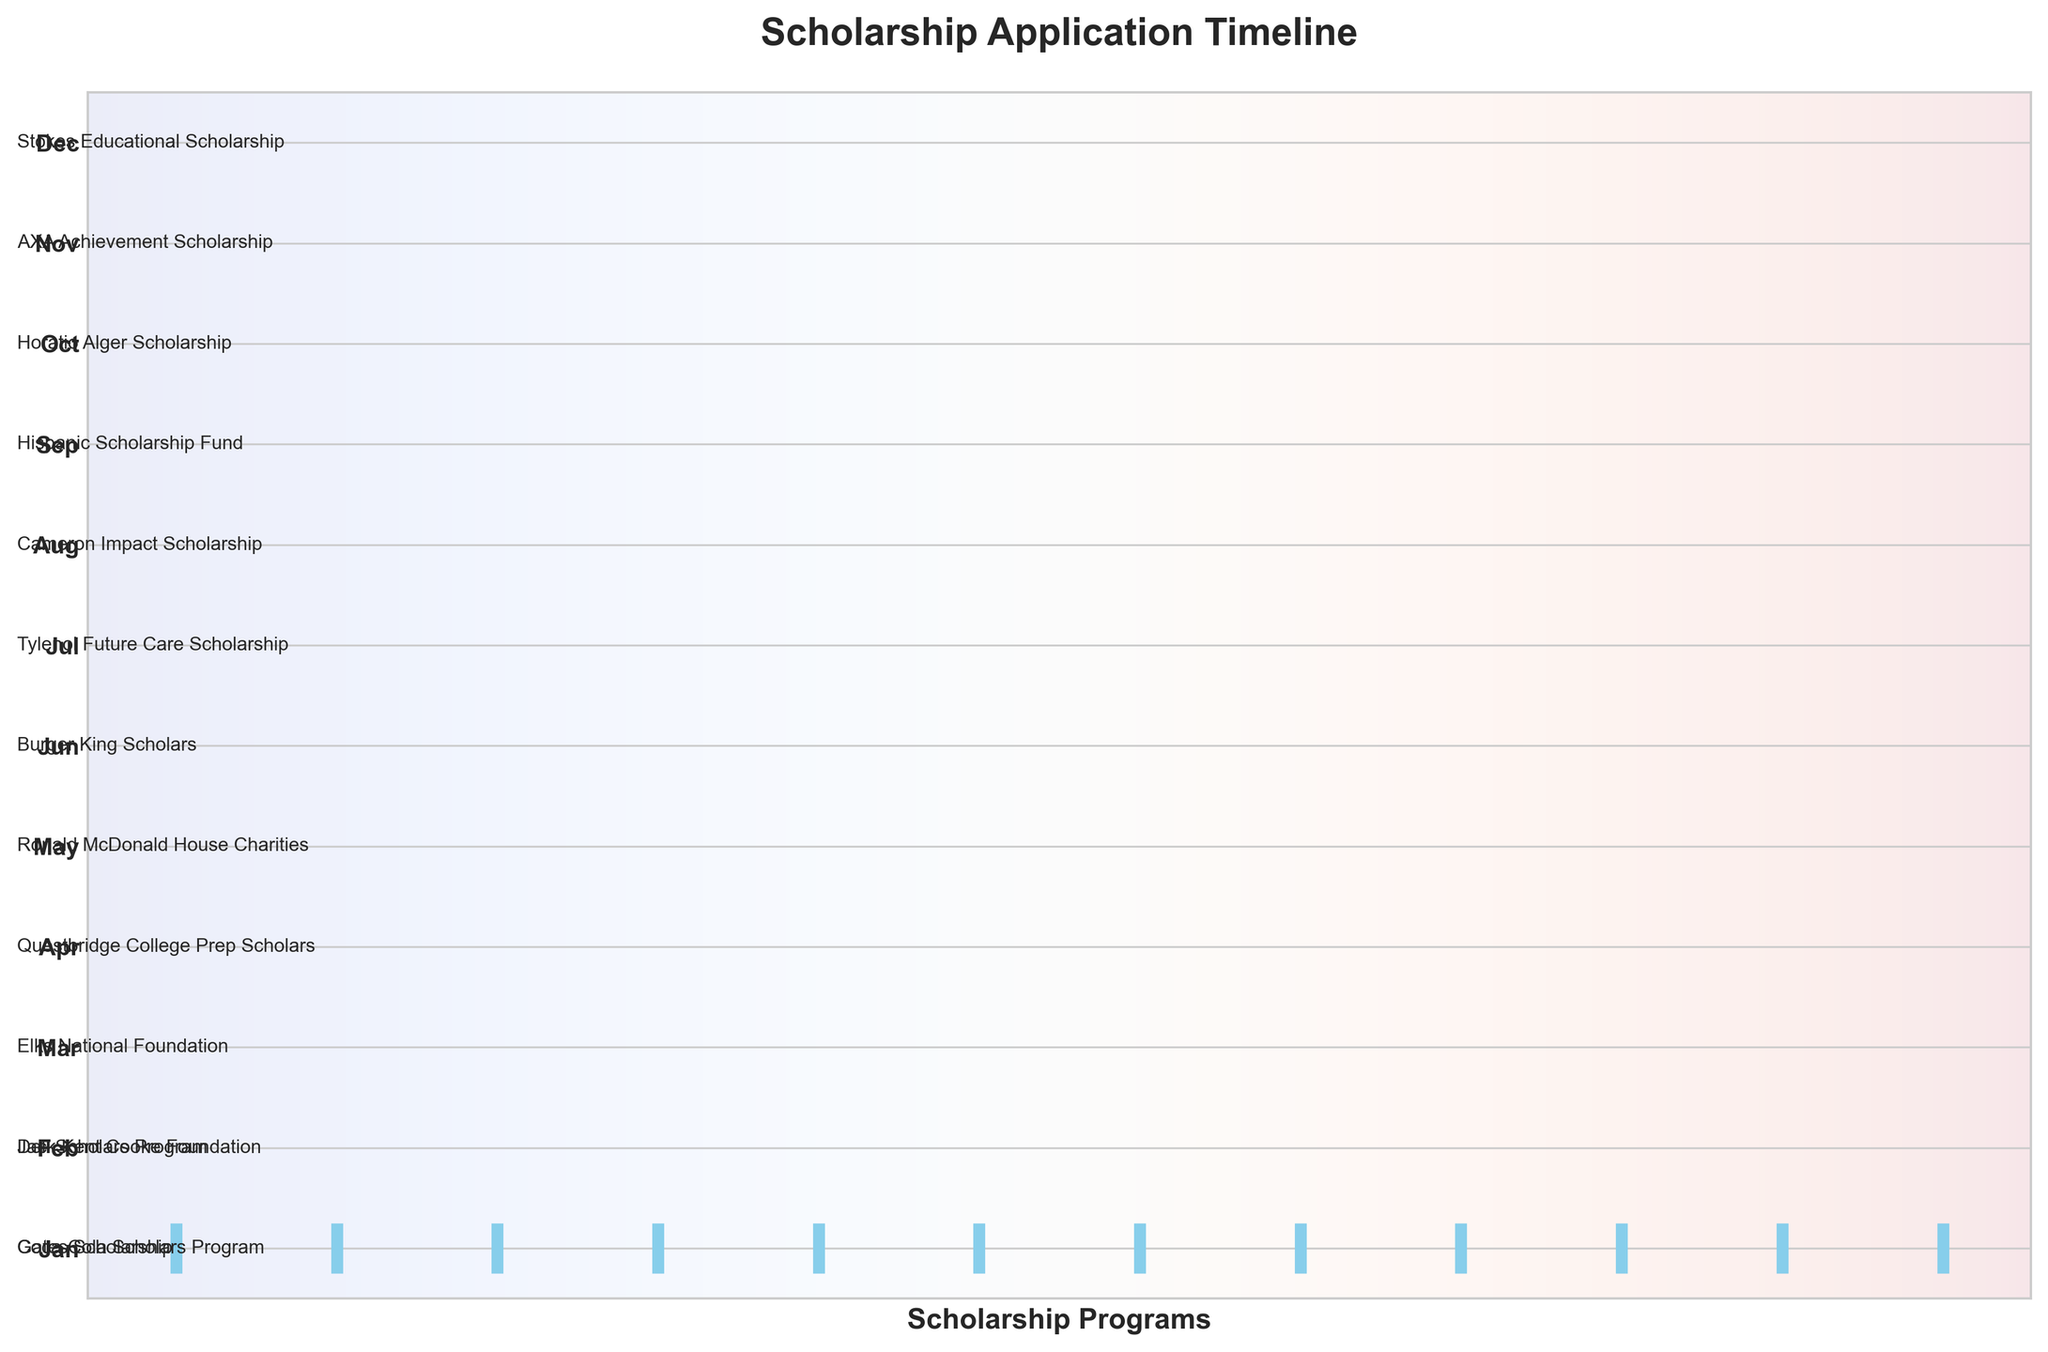What is the title of the plot? The title can be found at the top of the figure, usually in bold. In this case, it clearly states "Scholarship Application Timeline".
Answer: Scholarship Application Timeline How many months have scholarship applications? Count the number of unique months indicated on the y-axis. Each month has at least one corresponding scholarship event. There are 12 months displayed.
Answer: 12 Which month has the highest number of scholarship applications? By looking at the plot, you can count the number of scholarship names for each month. All months have one scholarship application listed.
Answer: All months have one Which scholarship is applied for in March? Check the y-axis label for March and look at the text annotation next to it. It shows the name "Elks National Foundation".
Answer: Elks National Foundation What is the color of the event lines? The lines representing the scholarship events are in a specific color. In this plot, the lines are colored sky blue.
Answer: Sky blue In which month is the Tylenol Future Care Scholarship available? Look for the name "Tylenol Future Care Scholarship" and trace it to the corresponding y-axis label, which is July.
Answer: July Which months have scholarship applications before June? List out the months with applications before June based on the plot: January, February, March, April, and May.
Answer: January, February, March, April, May How many scholarship applications occur from July to December? Count the number of scholarships listed from July to December. There is one in each month, so a total of six scholarships.
Answer: 6 Which scholarships are available in months starting with "A"? Look at the months starting with "A" (April and August) and check their corresponding scholarships: Questbridge College Prep Scholars and Cameron Impact Scholarship.
Answer: Questbridge College Prep Scholars and Cameron Impact Scholarship Are there more scholarship applications in the first half of the year or the second half? Count the number of applications from January to June (6) and compare them with July to December (6). Both halves of the year have equal numbers of applications.
Answer: Equal 